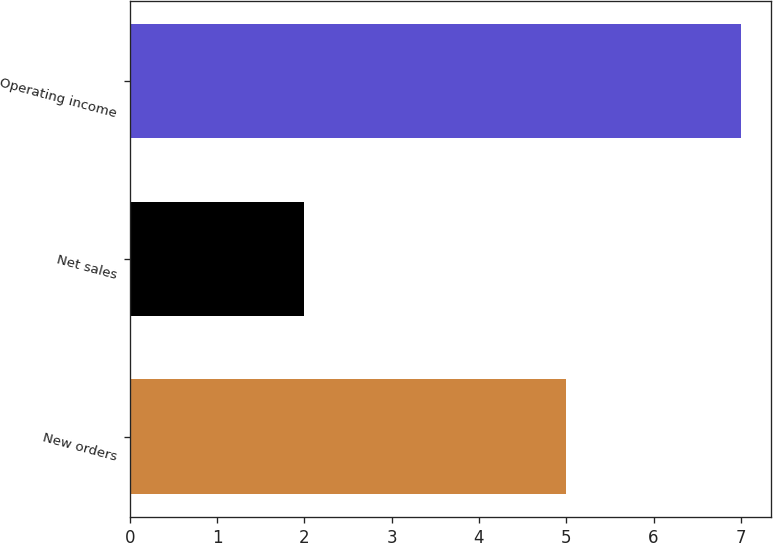Convert chart to OTSL. <chart><loc_0><loc_0><loc_500><loc_500><bar_chart><fcel>New orders<fcel>Net sales<fcel>Operating income<nl><fcel>5<fcel>2<fcel>7<nl></chart> 